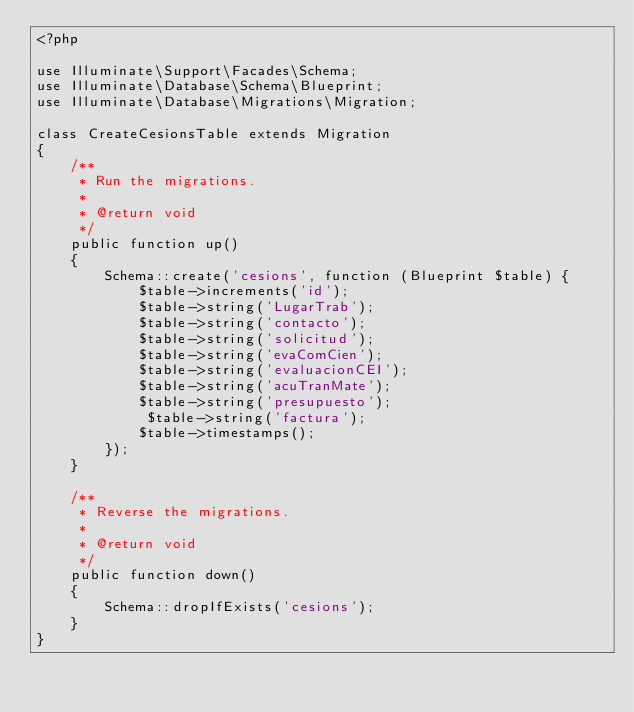Convert code to text. <code><loc_0><loc_0><loc_500><loc_500><_PHP_><?php

use Illuminate\Support\Facades\Schema;
use Illuminate\Database\Schema\Blueprint;
use Illuminate\Database\Migrations\Migration;

class CreateCesionsTable extends Migration
{
    /**
     * Run the migrations.
     *
     * @return void
     */
    public function up()
    {
        Schema::create('cesions', function (Blueprint $table) {
            $table->increments('id');
            $table->string('LugarTrab');
            $table->string('contacto');
            $table->string('solicitud');
            $table->string('evaComCien');
            $table->string('evaluacionCEI');
            $table->string('acuTranMate');
            $table->string('presupuesto');
             $table->string('factura');
            $table->timestamps();
        });
    }

    /**
     * Reverse the migrations.
     *
     * @return void
     */
    public function down()
    {
        Schema::dropIfExists('cesions');
    }
}
</code> 